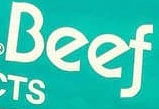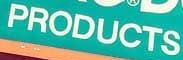What words can you see in these images in sequence, separated by a semicolon? Beef; PRODUCTS 